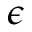Convert formula to latex. <formula><loc_0><loc_0><loc_500><loc_500>\epsilon</formula> 